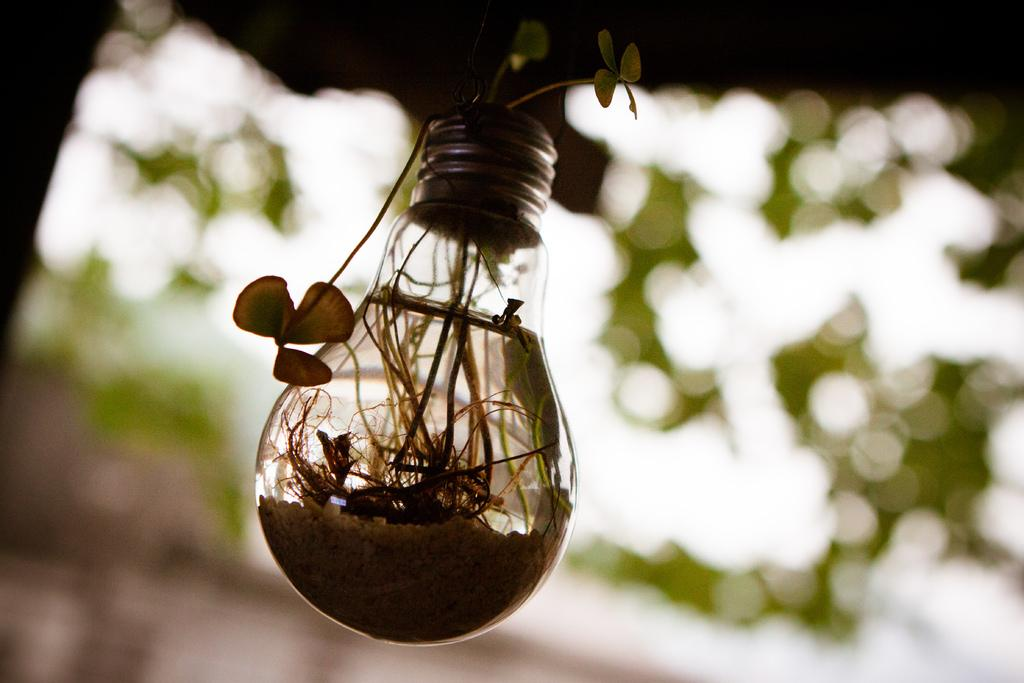What is inside the glass bulb in the image? There is a plant in a glass bulb in the image. Can you describe the liquid visible in the image? There is water visible in the image. What is the condition of the background in the image? The background of the image is blurry. What type of quiet treatment does the plant in the image require? The image does not provide information about the plant's treatment or any specific requirements, including quietness. 